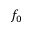Convert formula to latex. <formula><loc_0><loc_0><loc_500><loc_500>f _ { 0 }</formula> 